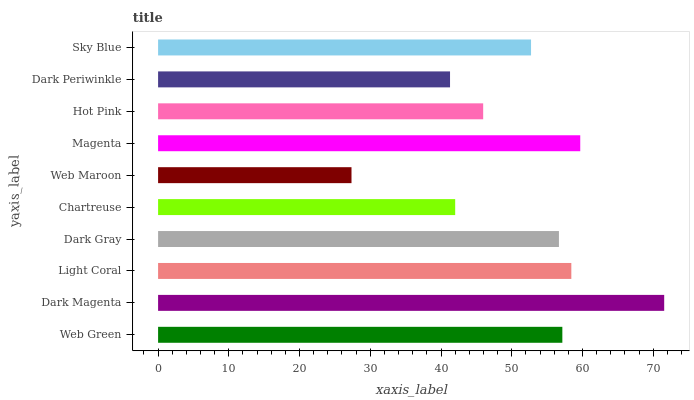Is Web Maroon the minimum?
Answer yes or no. Yes. Is Dark Magenta the maximum?
Answer yes or no. Yes. Is Light Coral the minimum?
Answer yes or no. No. Is Light Coral the maximum?
Answer yes or no. No. Is Dark Magenta greater than Light Coral?
Answer yes or no. Yes. Is Light Coral less than Dark Magenta?
Answer yes or no. Yes. Is Light Coral greater than Dark Magenta?
Answer yes or no. No. Is Dark Magenta less than Light Coral?
Answer yes or no. No. Is Dark Gray the high median?
Answer yes or no. Yes. Is Sky Blue the low median?
Answer yes or no. Yes. Is Sky Blue the high median?
Answer yes or no. No. Is Magenta the low median?
Answer yes or no. No. 